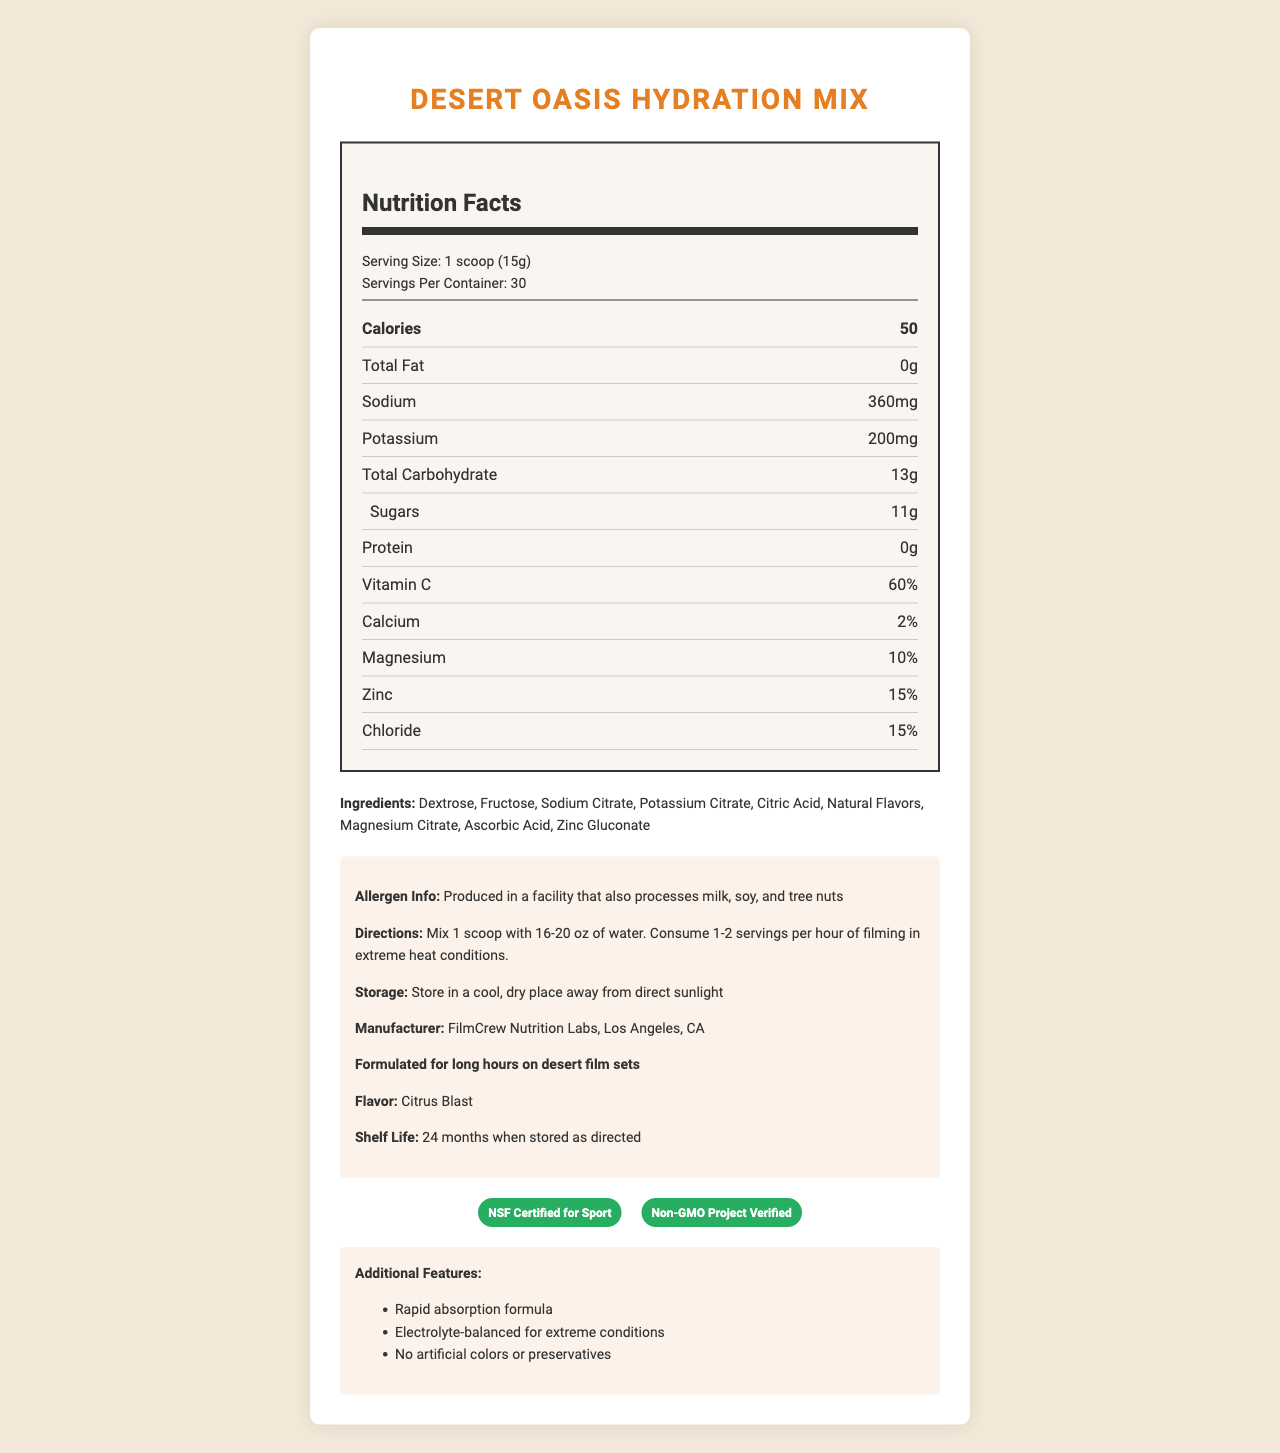how many calories are in one serving? The document lists the calorie content as 50 per serving.
Answer: 50 what is the serving size of Desert Oasis Hydration Mix? The document specifies the serving size as "1 scoop (15g)".
Answer: 1 scoop (15g) what is the main ingredient in the product? Dextrose is listed as the first ingredient, indicating it is the main ingredient.
Answer: Dextrose how much sodium is in one serving of the hydration mix? The document specifies that there are 360mg of sodium per serving.
Answer: 360mg what is the product manufacturer? The document lists the manufacturer as FilmCrew Nutrition Labs, Los Angeles, CA.
Answer: FilmCrew Nutrition Labs, Los Angeles, CA what is the flavor of the hydration mix? The flavor is mentioned as "Citrus Blast" in the document.
Answer: Citrus Blast how long is the shelf life of the product? The document specifies the shelf life is 24 months when stored as directed.
Answer: 24 months what storage instructions are provided for the product? The document advises storing the product in a cool, dry place away from direct sunlight.
Answer: Store in a cool, dry place away from direct sunlight what certifications does Desert Oasis Hydration Mix have? A. USDA Organic B. NSF Certified for Sport C. Non-GMO Project Verified D. Gluten-Free The document states the product is NSF Certified for Sport and Non-GMO Project Verified.
Answer: B, C how many carbohydrates are in one serving? A. 10g B. 12g C. 13g The document lists the total carbohydrate content as 13g per serving.
Answer: C is the product safe for someone with nut allergies? The document mentions that the product is produced in a facility that also processes tree nuts.
Answer: No does the product contain any artificial colors or preservatives? (True/False) The document states that the product has no artificial colors or preservatives.
Answer: False summarize the main information provided in the document. This summary encapsulates the key details presented in the document about the hydration mix.
Answer: The document details the Desert Oasis Hydration Mix's nutrition facts, ingredients, allergen information, directions for use, storage instructions, manufacturer, flavor, shelf life, certifications, and additional features. It highlights the nutrient content per serving, such as calories, sodium, potassium, carbohydrates, sugars, and vitamins, and lists certifications like NSF Certified for Sport and Non-GMO Project Verified. The product is designed for use in extreme heat conditions on film sets, with a rapid absorption formula and an electrolyte-balanced mix. how much sugar is in one serving of the product? The document specifies that each serving contains 11g of sugars.
Answer: 11g what kind of flavors does the product contain? The document lists natural flavors as one of the ingredients.
Answer: Natural Flavors can I mix the product with milk instead of water? The document only specifies water for mixing and mentions it is produced in a facility that processes milk, but it does not provide information on mixing with milk.
Answer: Not enough information 